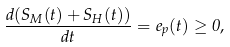Convert formula to latex. <formula><loc_0><loc_0><loc_500><loc_500>\frac { d ( S _ { M } ( t ) + S _ { H } ( t ) ) } { d t } = e _ { p } ( t ) \geq 0 ,</formula> 